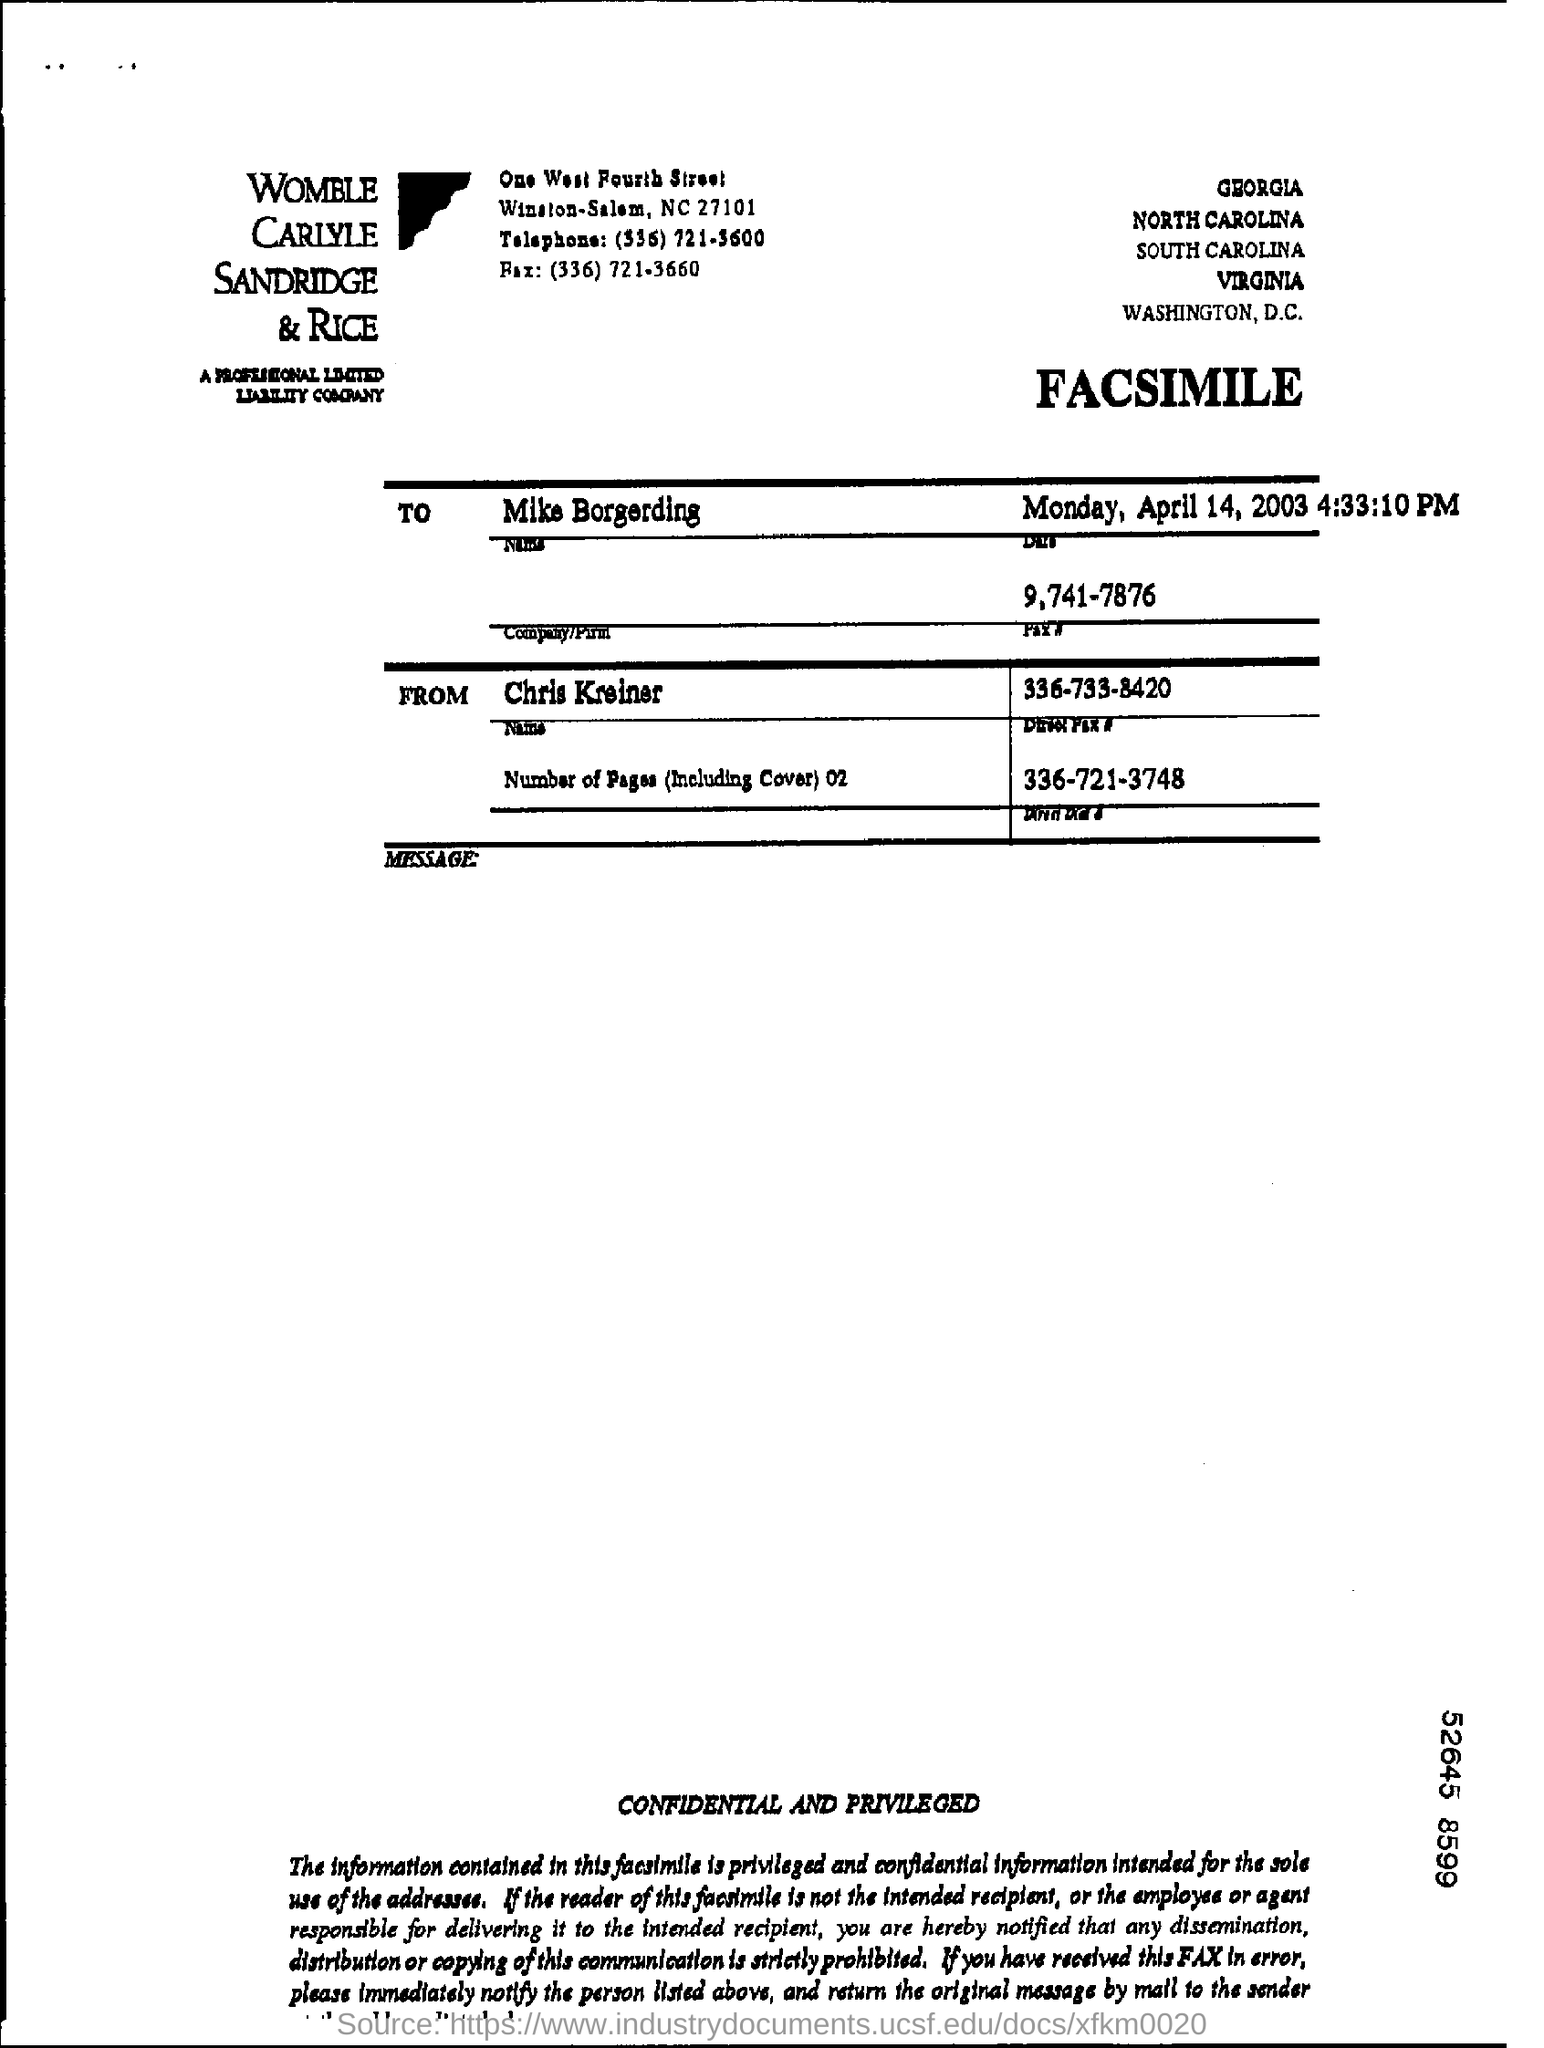Outline some significant characteristics in this image. The fax number of Mike is 9,741-7876. The recipient of the fax is Mike Borgerding. The fax is from Chris Kreiner. 